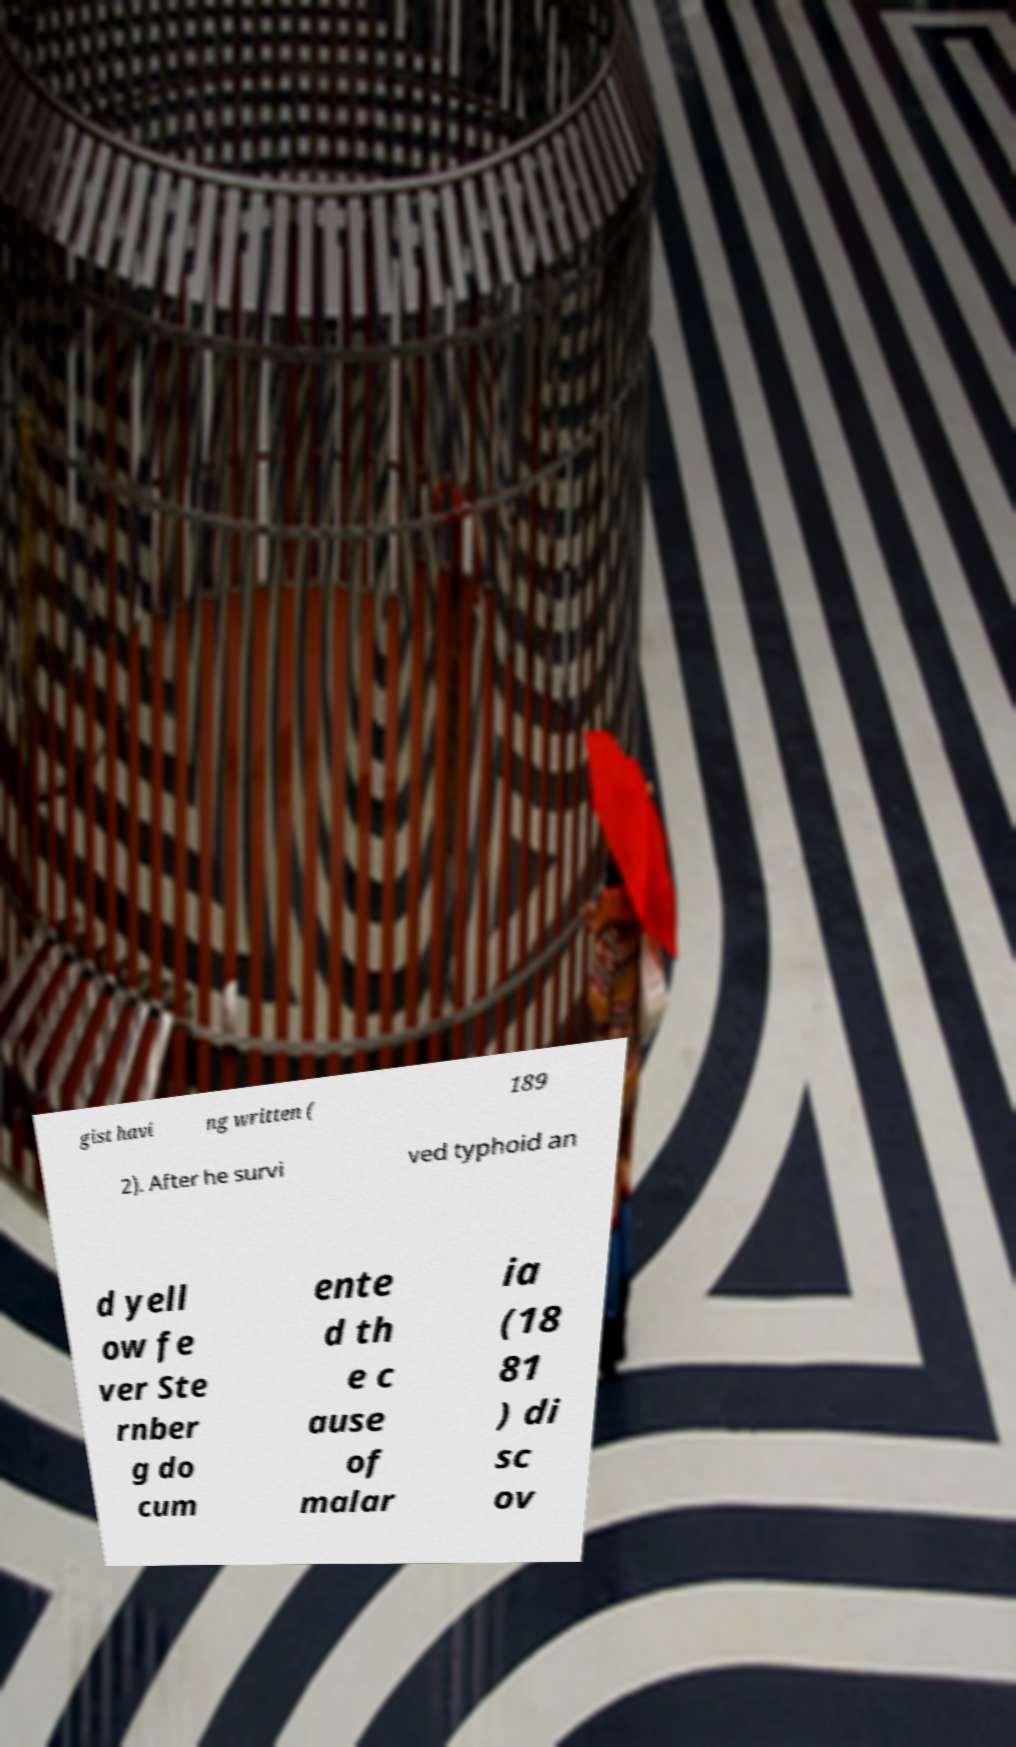I need the written content from this picture converted into text. Can you do that? gist havi ng written ( 189 2). After he survi ved typhoid an d yell ow fe ver Ste rnber g do cum ente d th e c ause of malar ia (18 81 ) di sc ov 